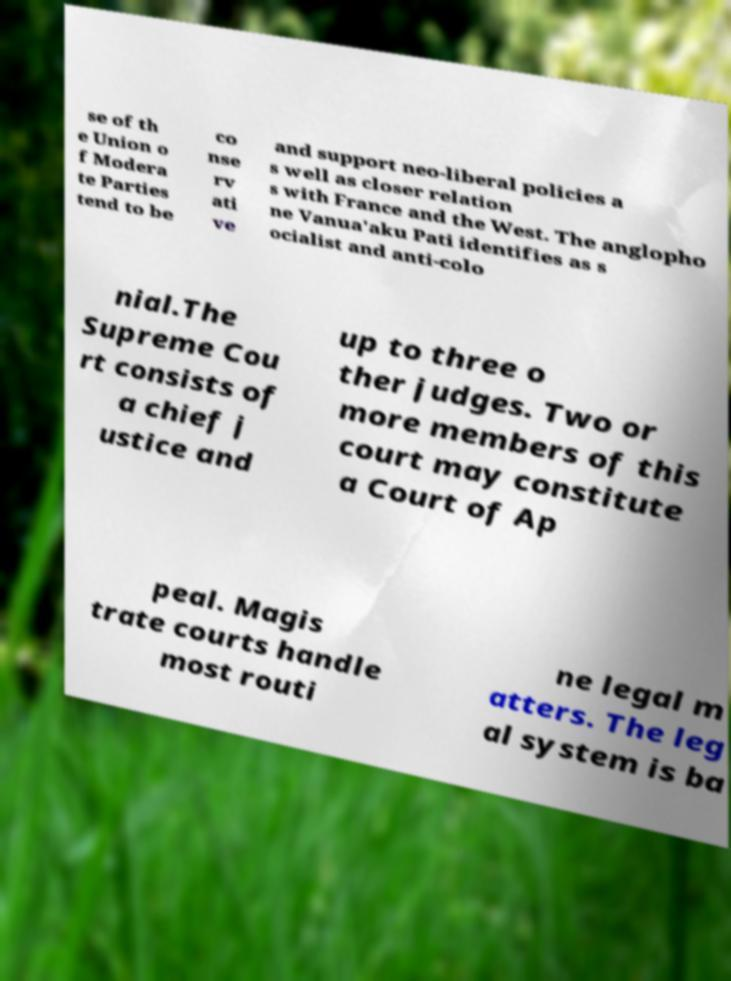I need the written content from this picture converted into text. Can you do that? se of th e Union o f Modera te Parties tend to be co nse rv ati ve and support neo-liberal policies a s well as closer relation s with France and the West. The anglopho ne Vanua'aku Pati identifies as s ocialist and anti-colo nial.The Supreme Cou rt consists of a chief j ustice and up to three o ther judges. Two or more members of this court may constitute a Court of Ap peal. Magis trate courts handle most routi ne legal m atters. The leg al system is ba 